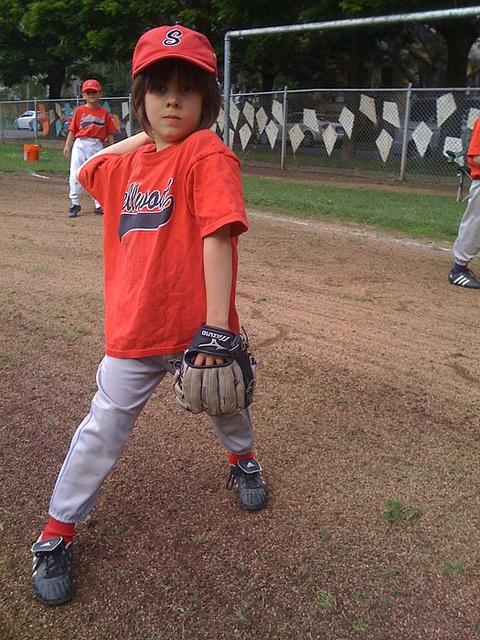What color is the child's hat?
Keep it brief. Red. What sport is the child playing?
Give a very brief answer. Baseball. What color is his shirt?
Be succinct. Orange. What is the girl doing?
Keep it brief. Throwing baseball. 